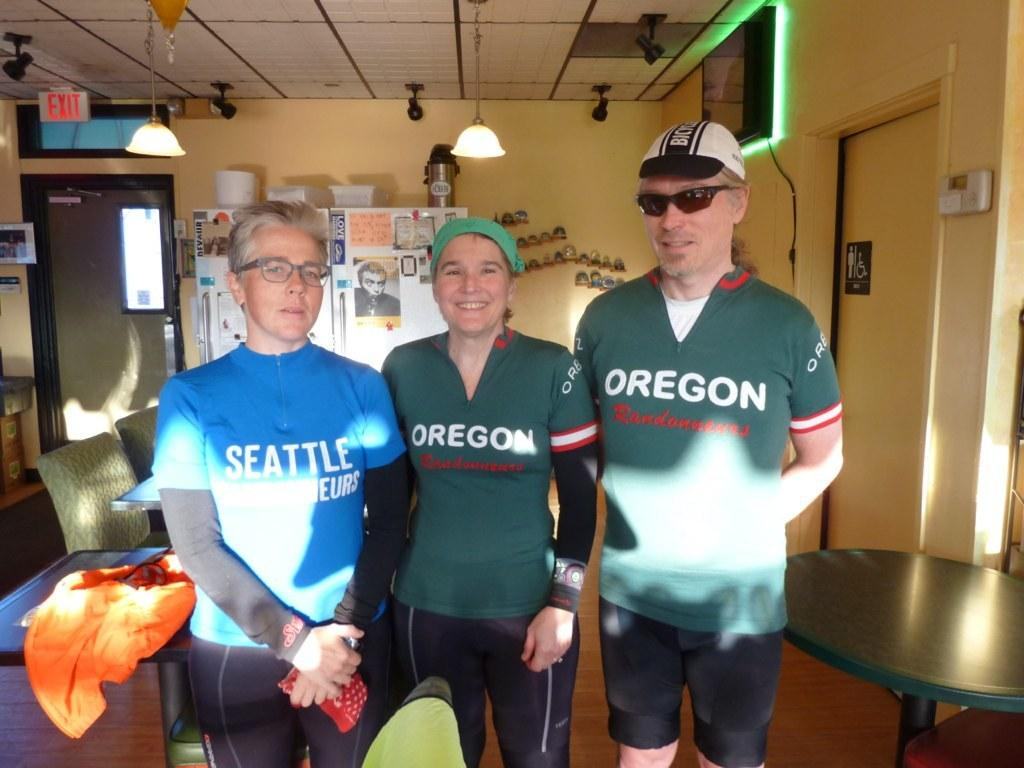<image>
Share a concise interpretation of the image provided. Three people in a room, two of whom are wearing green Oregon shirts. 